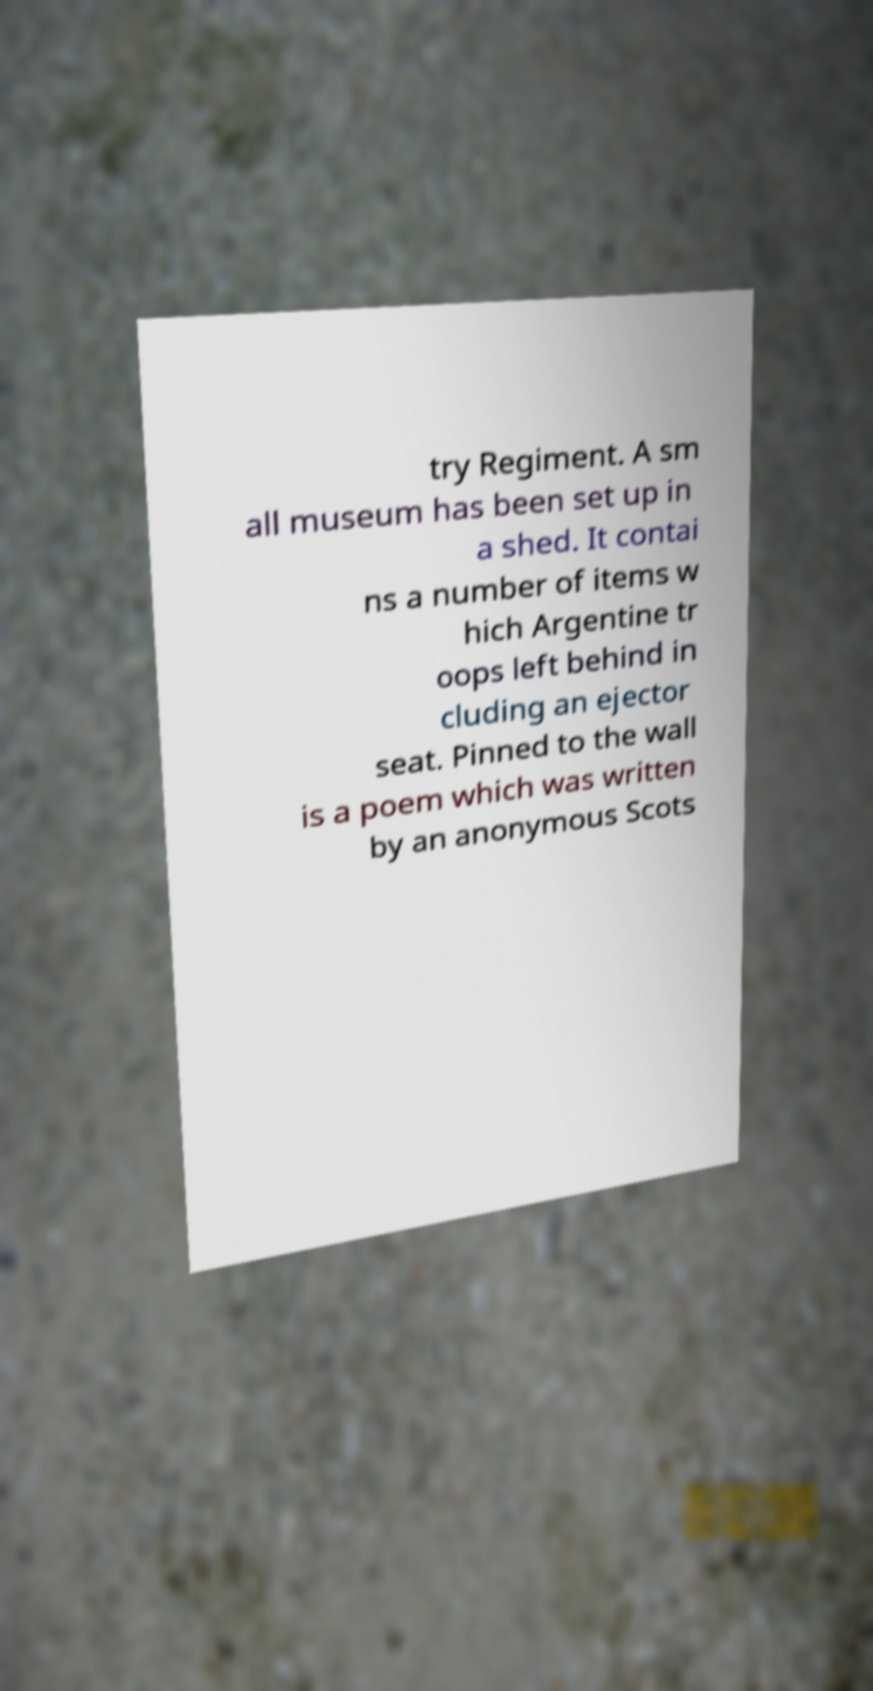Can you accurately transcribe the text from the provided image for me? try Regiment. A sm all museum has been set up in a shed. It contai ns a number of items w hich Argentine tr oops left behind in cluding an ejector seat. Pinned to the wall is a poem which was written by an anonymous Scots 